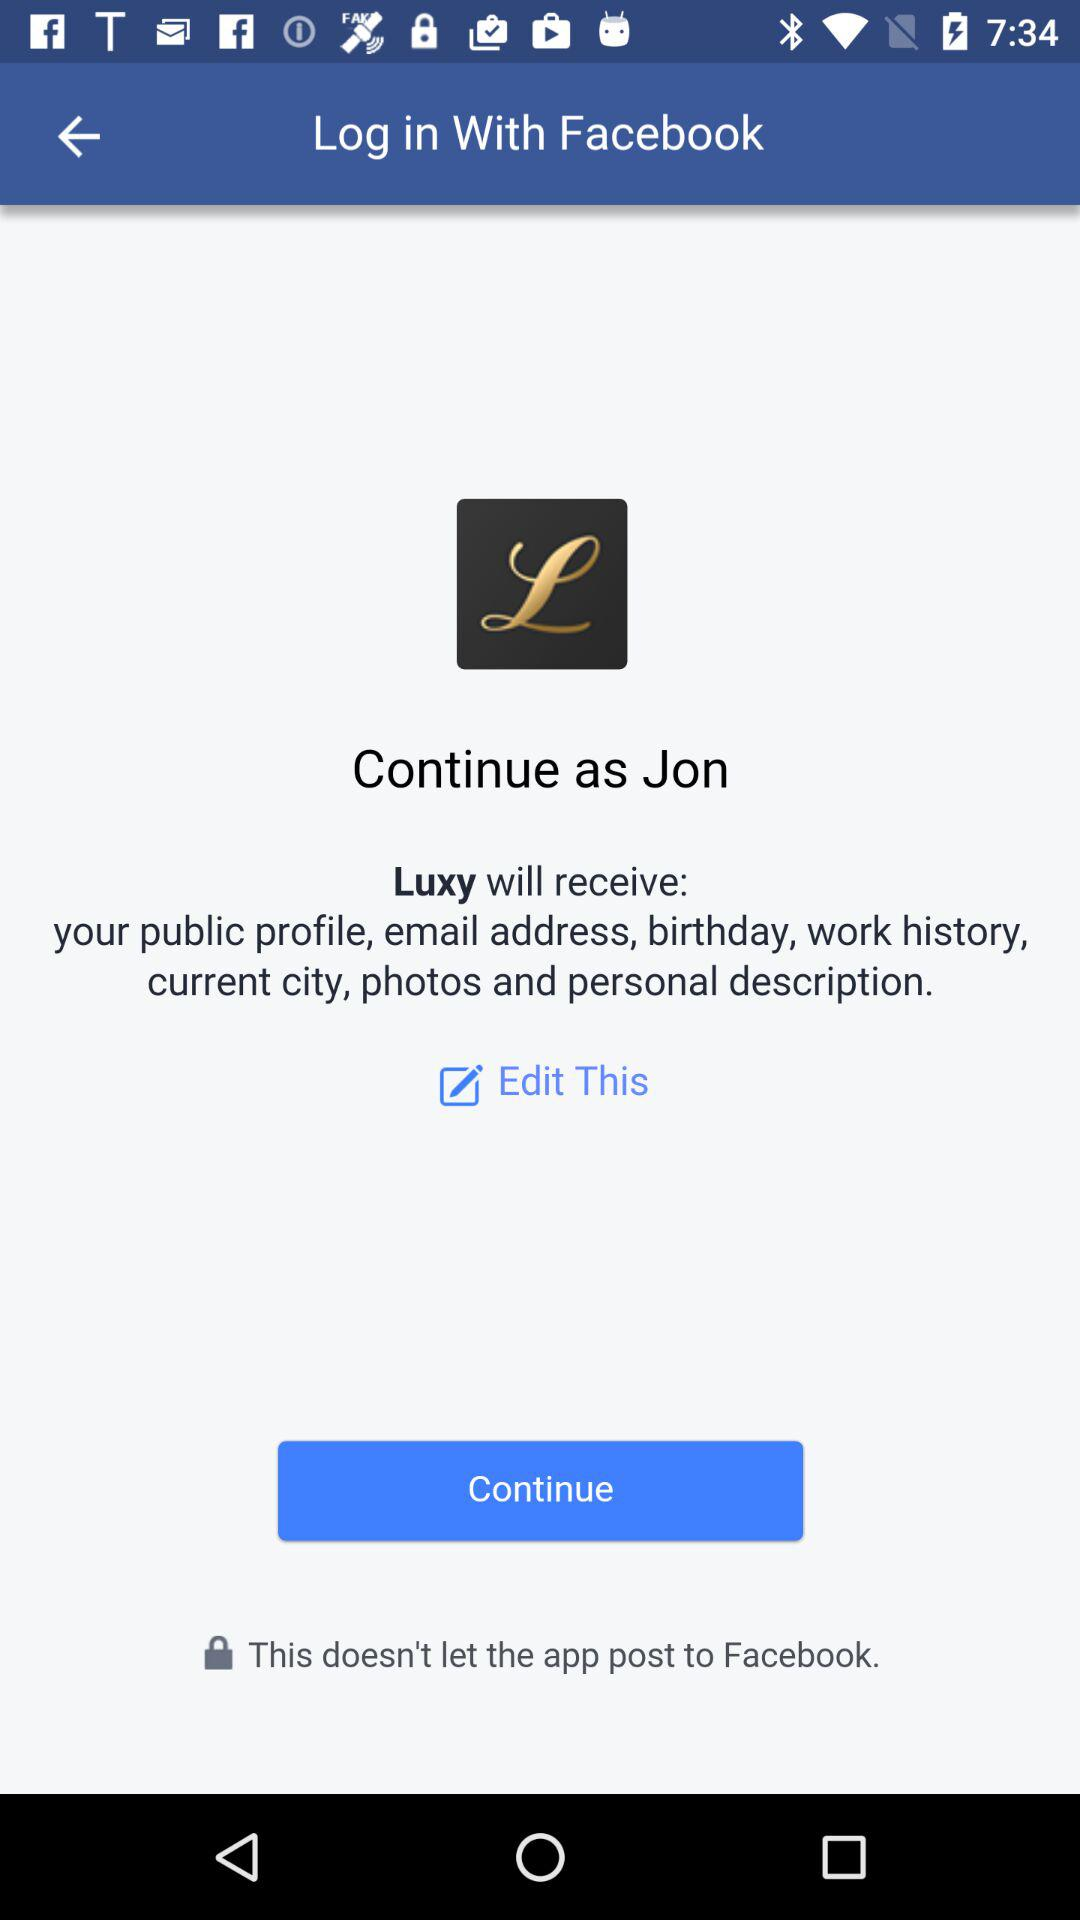What is the name of the application? The name of the application is "Luxy". 